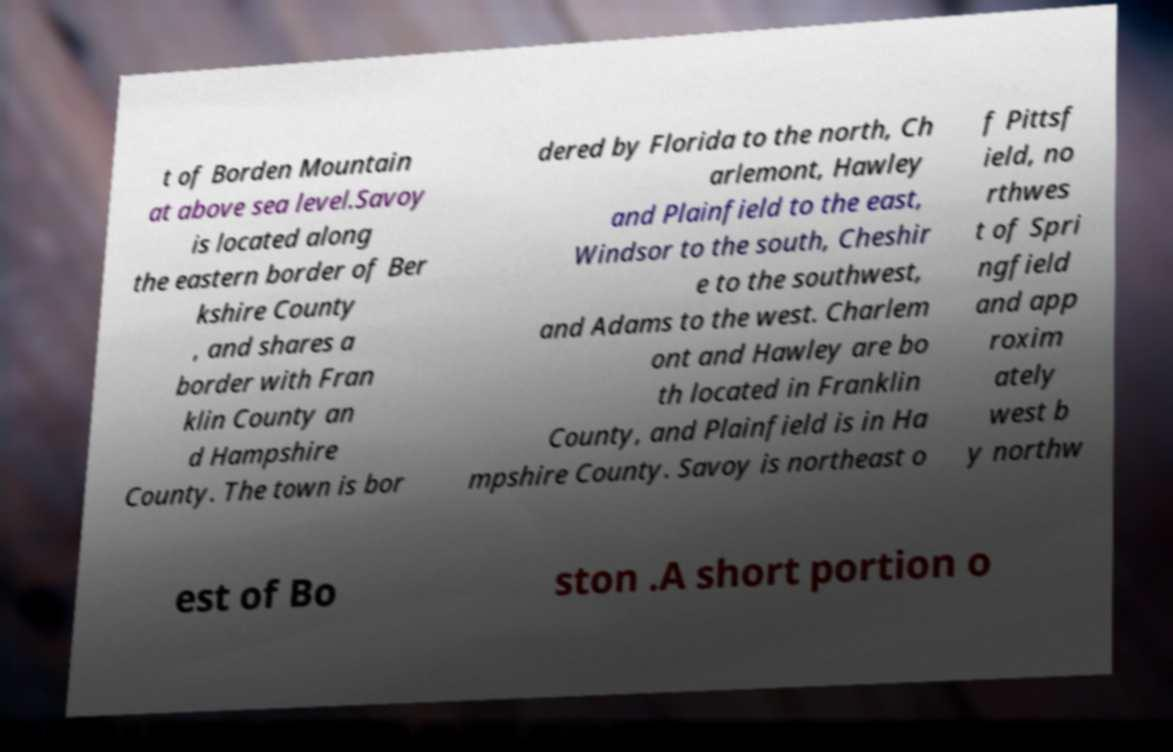Could you extract and type out the text from this image? t of Borden Mountain at above sea level.Savoy is located along the eastern border of Ber kshire County , and shares a border with Fran klin County an d Hampshire County. The town is bor dered by Florida to the north, Ch arlemont, Hawley and Plainfield to the east, Windsor to the south, Cheshir e to the southwest, and Adams to the west. Charlem ont and Hawley are bo th located in Franklin County, and Plainfield is in Ha mpshire County. Savoy is northeast o f Pittsf ield, no rthwes t of Spri ngfield and app roxim ately west b y northw est of Bo ston .A short portion o 